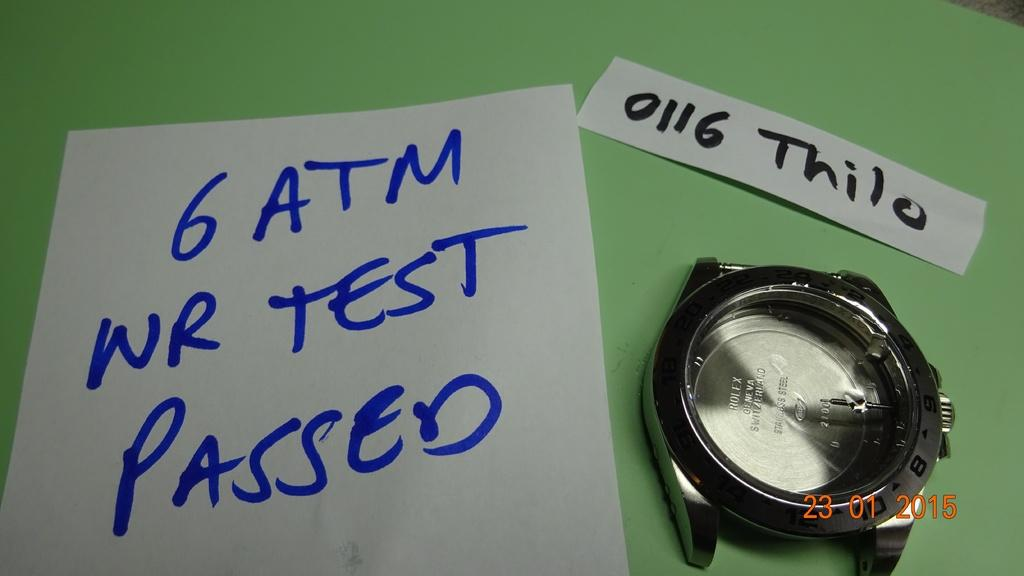<image>
Render a clear and concise summary of the photo. A broken watch on a table with a note that reads 6 ATM WR TEST PASSED. 